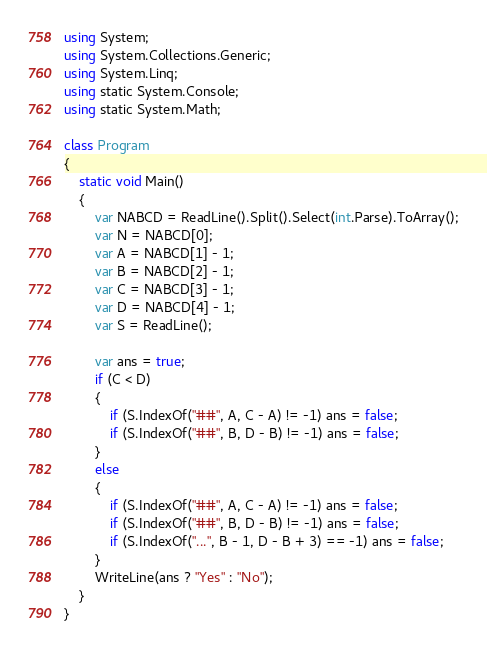Convert code to text. <code><loc_0><loc_0><loc_500><loc_500><_C#_>using System;
using System.Collections.Generic;
using System.Linq;
using static System.Console;
using static System.Math;

class Program
{
    static void Main()
    {
        var NABCD = ReadLine().Split().Select(int.Parse).ToArray();
        var N = NABCD[0];
        var A = NABCD[1] - 1;
        var B = NABCD[2] - 1;
        var C = NABCD[3] - 1;
        var D = NABCD[4] - 1;
        var S = ReadLine();

        var ans = true;
        if (C < D)
        {
            if (S.IndexOf("##", A, C - A) != -1) ans = false;
            if (S.IndexOf("##", B, D - B) != -1) ans = false;
        }
        else
        {
            if (S.IndexOf("##", A, C - A) != -1) ans = false;
            if (S.IndexOf("##", B, D - B) != -1) ans = false;
            if (S.IndexOf("...", B - 1, D - B + 3) == -1) ans = false;
        }
        WriteLine(ans ? "Yes" : "No");
    }
}</code> 